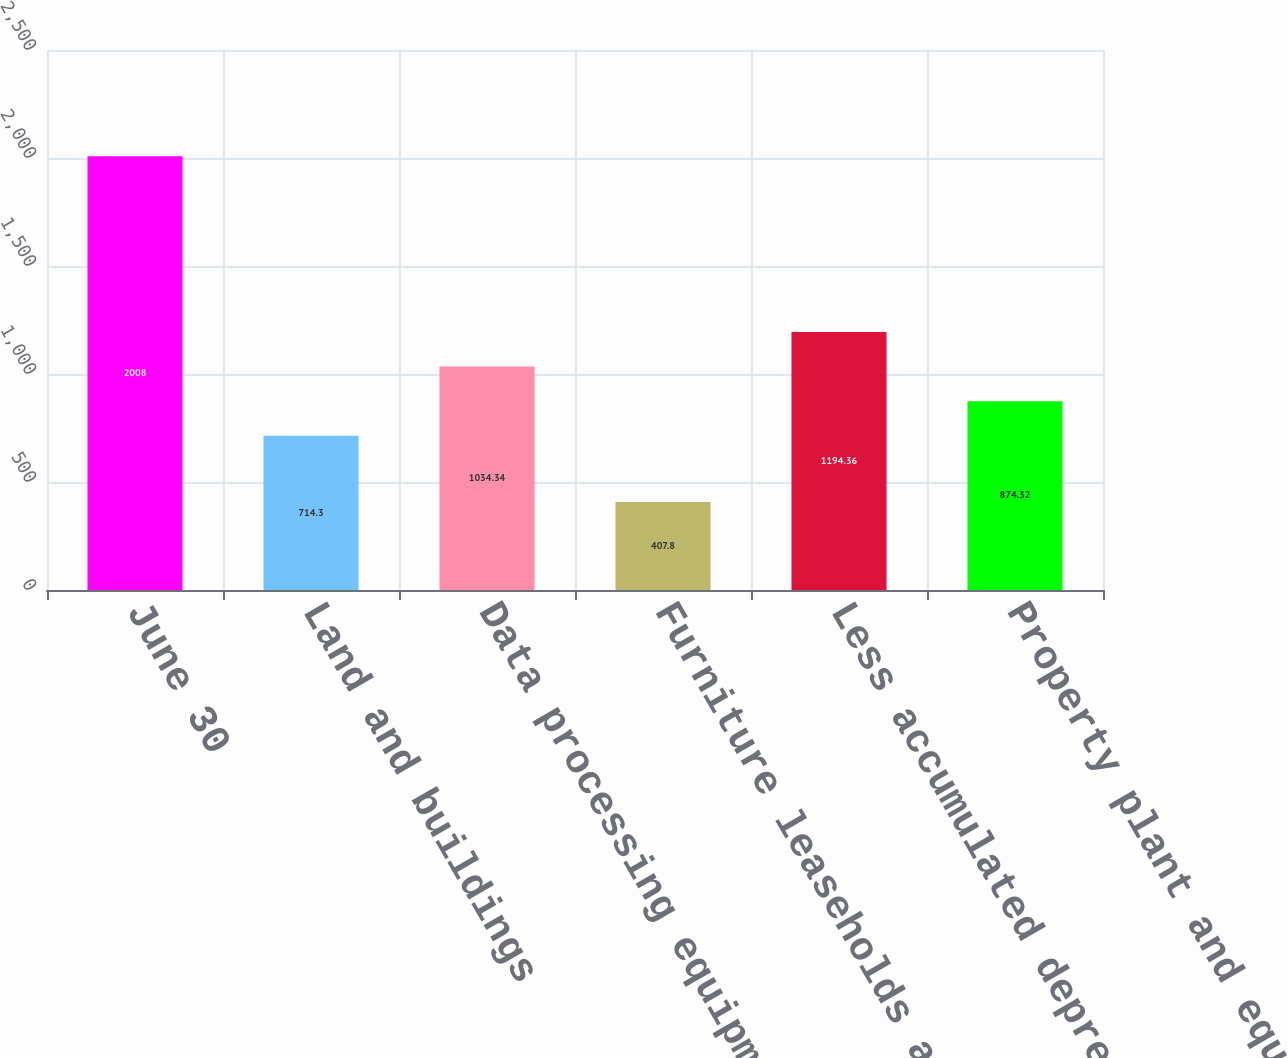Convert chart to OTSL. <chart><loc_0><loc_0><loc_500><loc_500><bar_chart><fcel>June 30<fcel>Land and buildings<fcel>Data processing equipment<fcel>Furniture leaseholds and other<fcel>Less accumulated depreciation<fcel>Property plant and equipment<nl><fcel>2008<fcel>714.3<fcel>1034.34<fcel>407.8<fcel>1194.36<fcel>874.32<nl></chart> 